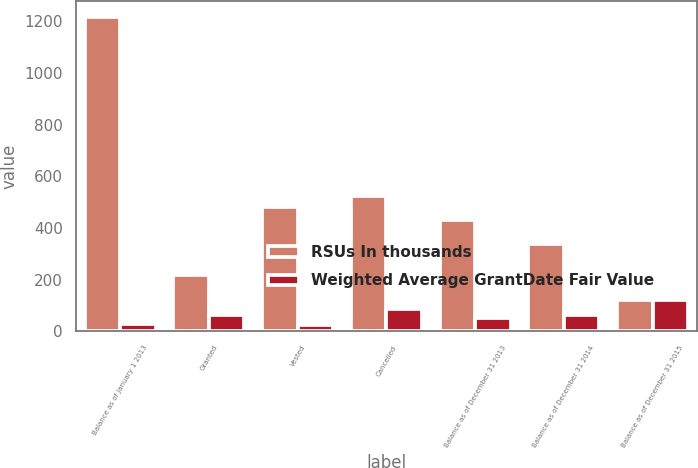<chart> <loc_0><loc_0><loc_500><loc_500><stacked_bar_chart><ecel><fcel>Balance as of January 1 2013<fcel>Granted<fcel>Vested<fcel>Cancelled<fcel>Balance as of December 31 2013<fcel>Balance as of December 31 2014<fcel>Balance as of December 31 2015<nl><fcel>RSUs In thousands<fcel>1218<fcel>216<fcel>480<fcel>522<fcel>432<fcel>337<fcel>119.2<nl><fcel>Weighted Average GrantDate Fair Value<fcel>29.57<fcel>63.04<fcel>23.29<fcel>86.1<fcel>50.64<fcel>61.97<fcel>119.2<nl></chart> 